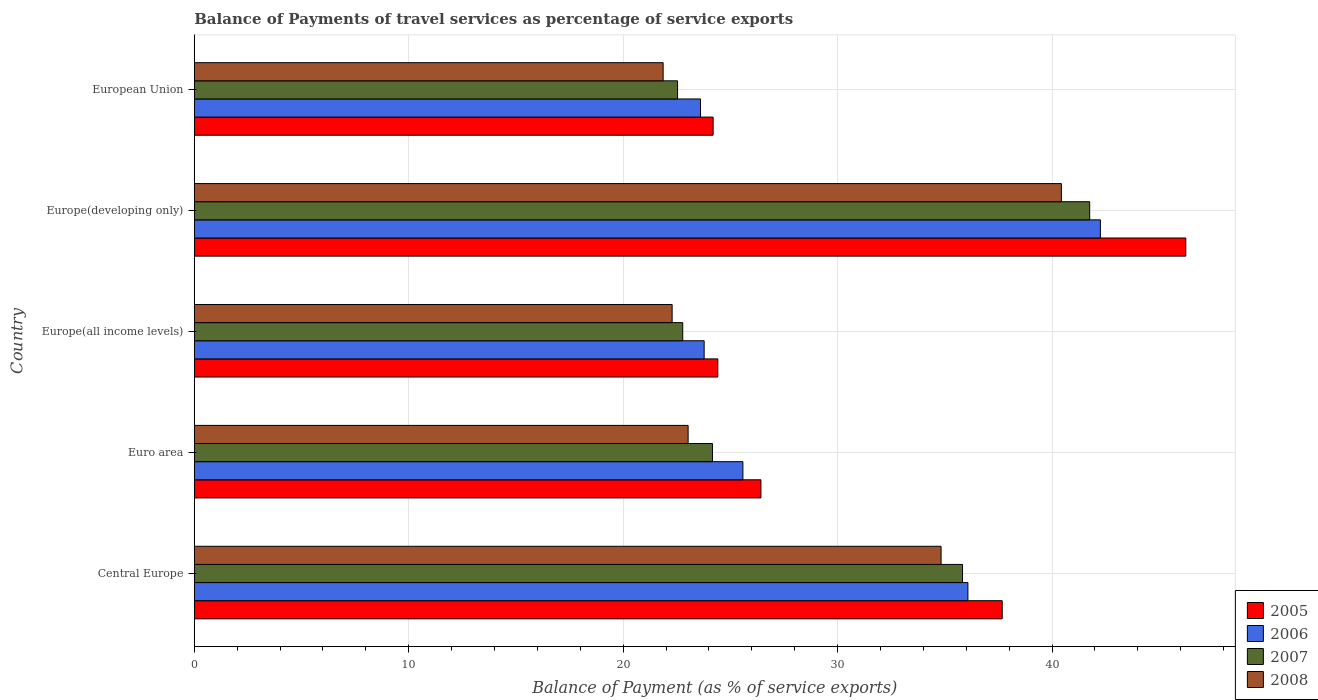How many different coloured bars are there?
Keep it short and to the point. 4. How many groups of bars are there?
Provide a succinct answer. 5. Are the number of bars per tick equal to the number of legend labels?
Provide a succinct answer. Yes. Are the number of bars on each tick of the Y-axis equal?
Ensure brevity in your answer.  Yes. How many bars are there on the 5th tick from the top?
Your response must be concise. 4. What is the balance of payments of travel services in 2005 in Europe(all income levels)?
Your answer should be very brief. 24.41. Across all countries, what is the maximum balance of payments of travel services in 2007?
Keep it short and to the point. 41.76. Across all countries, what is the minimum balance of payments of travel services in 2006?
Keep it short and to the point. 23.61. In which country was the balance of payments of travel services in 2005 maximum?
Give a very brief answer. Europe(developing only). What is the total balance of payments of travel services in 2005 in the graph?
Give a very brief answer. 158.95. What is the difference between the balance of payments of travel services in 2007 in Central Europe and that in Euro area?
Your answer should be very brief. 11.66. What is the difference between the balance of payments of travel services in 2005 in Europe(developing only) and the balance of payments of travel services in 2008 in European Union?
Your answer should be compact. 24.37. What is the average balance of payments of travel services in 2007 per country?
Provide a succinct answer. 29.41. What is the difference between the balance of payments of travel services in 2007 and balance of payments of travel services in 2005 in Euro area?
Offer a terse response. -2.26. What is the ratio of the balance of payments of travel services in 2006 in Europe(developing only) to that in European Union?
Ensure brevity in your answer.  1.79. Is the balance of payments of travel services in 2006 in Euro area less than that in Europe(developing only)?
Provide a short and direct response. Yes. What is the difference between the highest and the second highest balance of payments of travel services in 2005?
Provide a succinct answer. 8.56. What is the difference between the highest and the lowest balance of payments of travel services in 2005?
Offer a terse response. 22.04. Is the sum of the balance of payments of travel services in 2007 in Central Europe and Euro area greater than the maximum balance of payments of travel services in 2006 across all countries?
Your answer should be compact. Yes. What does the 1st bar from the top in European Union represents?
Your answer should be compact. 2008. What does the 4th bar from the bottom in European Union represents?
Your response must be concise. 2008. How many bars are there?
Make the answer very short. 20. Are all the bars in the graph horizontal?
Make the answer very short. Yes. How many countries are there in the graph?
Provide a succinct answer. 5. Does the graph contain grids?
Keep it short and to the point. Yes. How many legend labels are there?
Offer a terse response. 4. How are the legend labels stacked?
Your answer should be compact. Vertical. What is the title of the graph?
Keep it short and to the point. Balance of Payments of travel services as percentage of service exports. Does "1992" appear as one of the legend labels in the graph?
Your answer should be very brief. No. What is the label or title of the X-axis?
Provide a short and direct response. Balance of Payment (as % of service exports). What is the label or title of the Y-axis?
Make the answer very short. Country. What is the Balance of Payment (as % of service exports) in 2005 in Central Europe?
Provide a short and direct response. 37.68. What is the Balance of Payment (as % of service exports) of 2006 in Central Europe?
Keep it short and to the point. 36.08. What is the Balance of Payment (as % of service exports) in 2007 in Central Europe?
Ensure brevity in your answer.  35.83. What is the Balance of Payment (as % of service exports) of 2008 in Central Europe?
Keep it short and to the point. 34.83. What is the Balance of Payment (as % of service exports) of 2005 in Euro area?
Keep it short and to the point. 26.42. What is the Balance of Payment (as % of service exports) in 2006 in Euro area?
Offer a terse response. 25.58. What is the Balance of Payment (as % of service exports) in 2007 in Euro area?
Make the answer very short. 24.17. What is the Balance of Payment (as % of service exports) in 2008 in Euro area?
Provide a short and direct response. 23.03. What is the Balance of Payment (as % of service exports) in 2005 in Europe(all income levels)?
Offer a very short reply. 24.41. What is the Balance of Payment (as % of service exports) in 2006 in Europe(all income levels)?
Your answer should be compact. 23.78. What is the Balance of Payment (as % of service exports) in 2007 in Europe(all income levels)?
Your answer should be very brief. 22.78. What is the Balance of Payment (as % of service exports) in 2008 in Europe(all income levels)?
Your response must be concise. 22.28. What is the Balance of Payment (as % of service exports) of 2005 in Europe(developing only)?
Offer a terse response. 46.24. What is the Balance of Payment (as % of service exports) of 2006 in Europe(developing only)?
Offer a terse response. 42.25. What is the Balance of Payment (as % of service exports) of 2007 in Europe(developing only)?
Offer a terse response. 41.76. What is the Balance of Payment (as % of service exports) of 2008 in Europe(developing only)?
Offer a very short reply. 40.43. What is the Balance of Payment (as % of service exports) in 2005 in European Union?
Your response must be concise. 24.19. What is the Balance of Payment (as % of service exports) in 2006 in European Union?
Your response must be concise. 23.61. What is the Balance of Payment (as % of service exports) in 2007 in European Union?
Give a very brief answer. 22.54. What is the Balance of Payment (as % of service exports) of 2008 in European Union?
Provide a succinct answer. 21.86. Across all countries, what is the maximum Balance of Payment (as % of service exports) of 2005?
Keep it short and to the point. 46.24. Across all countries, what is the maximum Balance of Payment (as % of service exports) in 2006?
Ensure brevity in your answer.  42.25. Across all countries, what is the maximum Balance of Payment (as % of service exports) in 2007?
Make the answer very short. 41.76. Across all countries, what is the maximum Balance of Payment (as % of service exports) of 2008?
Your answer should be very brief. 40.43. Across all countries, what is the minimum Balance of Payment (as % of service exports) in 2005?
Offer a terse response. 24.19. Across all countries, what is the minimum Balance of Payment (as % of service exports) of 2006?
Offer a very short reply. 23.61. Across all countries, what is the minimum Balance of Payment (as % of service exports) of 2007?
Keep it short and to the point. 22.54. Across all countries, what is the minimum Balance of Payment (as % of service exports) in 2008?
Your answer should be very brief. 21.86. What is the total Balance of Payment (as % of service exports) in 2005 in the graph?
Provide a succinct answer. 158.95. What is the total Balance of Payment (as % of service exports) in 2006 in the graph?
Provide a short and direct response. 151.3. What is the total Balance of Payment (as % of service exports) of 2007 in the graph?
Keep it short and to the point. 147.06. What is the total Balance of Payment (as % of service exports) in 2008 in the graph?
Provide a succinct answer. 142.44. What is the difference between the Balance of Payment (as % of service exports) in 2005 in Central Europe and that in Euro area?
Provide a short and direct response. 11.25. What is the difference between the Balance of Payment (as % of service exports) of 2006 in Central Europe and that in Euro area?
Keep it short and to the point. 10.49. What is the difference between the Balance of Payment (as % of service exports) in 2007 in Central Europe and that in Euro area?
Your answer should be compact. 11.66. What is the difference between the Balance of Payment (as % of service exports) in 2008 in Central Europe and that in Euro area?
Your answer should be compact. 11.8. What is the difference between the Balance of Payment (as % of service exports) in 2005 in Central Europe and that in Europe(all income levels)?
Offer a very short reply. 13.26. What is the difference between the Balance of Payment (as % of service exports) in 2006 in Central Europe and that in Europe(all income levels)?
Make the answer very short. 12.3. What is the difference between the Balance of Payment (as % of service exports) of 2007 in Central Europe and that in Europe(all income levels)?
Offer a very short reply. 13.05. What is the difference between the Balance of Payment (as % of service exports) in 2008 in Central Europe and that in Europe(all income levels)?
Your response must be concise. 12.54. What is the difference between the Balance of Payment (as % of service exports) in 2005 in Central Europe and that in Europe(developing only)?
Your answer should be very brief. -8.56. What is the difference between the Balance of Payment (as % of service exports) in 2006 in Central Europe and that in Europe(developing only)?
Make the answer very short. -6.18. What is the difference between the Balance of Payment (as % of service exports) in 2007 in Central Europe and that in Europe(developing only)?
Make the answer very short. -5.93. What is the difference between the Balance of Payment (as % of service exports) of 2008 in Central Europe and that in Europe(developing only)?
Offer a very short reply. -5.61. What is the difference between the Balance of Payment (as % of service exports) of 2005 in Central Europe and that in European Union?
Provide a succinct answer. 13.48. What is the difference between the Balance of Payment (as % of service exports) of 2006 in Central Europe and that in European Union?
Make the answer very short. 12.47. What is the difference between the Balance of Payment (as % of service exports) of 2007 in Central Europe and that in European Union?
Make the answer very short. 13.29. What is the difference between the Balance of Payment (as % of service exports) in 2008 in Central Europe and that in European Union?
Your answer should be compact. 12.96. What is the difference between the Balance of Payment (as % of service exports) in 2005 in Euro area and that in Europe(all income levels)?
Ensure brevity in your answer.  2.01. What is the difference between the Balance of Payment (as % of service exports) in 2006 in Euro area and that in Europe(all income levels)?
Offer a very short reply. 1.81. What is the difference between the Balance of Payment (as % of service exports) of 2007 in Euro area and that in Europe(all income levels)?
Your answer should be very brief. 1.39. What is the difference between the Balance of Payment (as % of service exports) in 2008 in Euro area and that in Europe(all income levels)?
Offer a terse response. 0.75. What is the difference between the Balance of Payment (as % of service exports) in 2005 in Euro area and that in Europe(developing only)?
Ensure brevity in your answer.  -19.81. What is the difference between the Balance of Payment (as % of service exports) in 2006 in Euro area and that in Europe(developing only)?
Give a very brief answer. -16.67. What is the difference between the Balance of Payment (as % of service exports) of 2007 in Euro area and that in Europe(developing only)?
Keep it short and to the point. -17.59. What is the difference between the Balance of Payment (as % of service exports) in 2008 in Euro area and that in Europe(developing only)?
Ensure brevity in your answer.  -17.41. What is the difference between the Balance of Payment (as % of service exports) in 2005 in Euro area and that in European Union?
Give a very brief answer. 2.23. What is the difference between the Balance of Payment (as % of service exports) in 2006 in Euro area and that in European Union?
Keep it short and to the point. 1.98. What is the difference between the Balance of Payment (as % of service exports) in 2007 in Euro area and that in European Union?
Offer a terse response. 1.63. What is the difference between the Balance of Payment (as % of service exports) of 2008 in Euro area and that in European Union?
Provide a short and direct response. 1.17. What is the difference between the Balance of Payment (as % of service exports) of 2005 in Europe(all income levels) and that in Europe(developing only)?
Your answer should be compact. -21.82. What is the difference between the Balance of Payment (as % of service exports) in 2006 in Europe(all income levels) and that in Europe(developing only)?
Give a very brief answer. -18.48. What is the difference between the Balance of Payment (as % of service exports) in 2007 in Europe(all income levels) and that in Europe(developing only)?
Give a very brief answer. -18.98. What is the difference between the Balance of Payment (as % of service exports) in 2008 in Europe(all income levels) and that in Europe(developing only)?
Your response must be concise. -18.15. What is the difference between the Balance of Payment (as % of service exports) of 2005 in Europe(all income levels) and that in European Union?
Your answer should be compact. 0.22. What is the difference between the Balance of Payment (as % of service exports) of 2006 in Europe(all income levels) and that in European Union?
Offer a very short reply. 0.17. What is the difference between the Balance of Payment (as % of service exports) in 2007 in Europe(all income levels) and that in European Union?
Give a very brief answer. 0.24. What is the difference between the Balance of Payment (as % of service exports) of 2008 in Europe(all income levels) and that in European Union?
Your answer should be very brief. 0.42. What is the difference between the Balance of Payment (as % of service exports) in 2005 in Europe(developing only) and that in European Union?
Offer a terse response. 22.04. What is the difference between the Balance of Payment (as % of service exports) in 2006 in Europe(developing only) and that in European Union?
Ensure brevity in your answer.  18.65. What is the difference between the Balance of Payment (as % of service exports) in 2007 in Europe(developing only) and that in European Union?
Keep it short and to the point. 19.22. What is the difference between the Balance of Payment (as % of service exports) in 2008 in Europe(developing only) and that in European Union?
Your response must be concise. 18.57. What is the difference between the Balance of Payment (as % of service exports) of 2005 in Central Europe and the Balance of Payment (as % of service exports) of 2006 in Euro area?
Offer a very short reply. 12.09. What is the difference between the Balance of Payment (as % of service exports) of 2005 in Central Europe and the Balance of Payment (as % of service exports) of 2007 in Euro area?
Your answer should be compact. 13.51. What is the difference between the Balance of Payment (as % of service exports) of 2005 in Central Europe and the Balance of Payment (as % of service exports) of 2008 in Euro area?
Provide a succinct answer. 14.65. What is the difference between the Balance of Payment (as % of service exports) of 2006 in Central Europe and the Balance of Payment (as % of service exports) of 2007 in Euro area?
Provide a short and direct response. 11.91. What is the difference between the Balance of Payment (as % of service exports) in 2006 in Central Europe and the Balance of Payment (as % of service exports) in 2008 in Euro area?
Your answer should be compact. 13.05. What is the difference between the Balance of Payment (as % of service exports) of 2007 in Central Europe and the Balance of Payment (as % of service exports) of 2008 in Euro area?
Give a very brief answer. 12.8. What is the difference between the Balance of Payment (as % of service exports) in 2005 in Central Europe and the Balance of Payment (as % of service exports) in 2006 in Europe(all income levels)?
Provide a succinct answer. 13.9. What is the difference between the Balance of Payment (as % of service exports) of 2005 in Central Europe and the Balance of Payment (as % of service exports) of 2007 in Europe(all income levels)?
Provide a succinct answer. 14.9. What is the difference between the Balance of Payment (as % of service exports) of 2005 in Central Europe and the Balance of Payment (as % of service exports) of 2008 in Europe(all income levels)?
Provide a succinct answer. 15.39. What is the difference between the Balance of Payment (as % of service exports) of 2006 in Central Europe and the Balance of Payment (as % of service exports) of 2007 in Europe(all income levels)?
Keep it short and to the point. 13.3. What is the difference between the Balance of Payment (as % of service exports) of 2006 in Central Europe and the Balance of Payment (as % of service exports) of 2008 in Europe(all income levels)?
Provide a succinct answer. 13.79. What is the difference between the Balance of Payment (as % of service exports) in 2007 in Central Europe and the Balance of Payment (as % of service exports) in 2008 in Europe(all income levels)?
Offer a very short reply. 13.54. What is the difference between the Balance of Payment (as % of service exports) in 2005 in Central Europe and the Balance of Payment (as % of service exports) in 2006 in Europe(developing only)?
Offer a very short reply. -4.58. What is the difference between the Balance of Payment (as % of service exports) in 2005 in Central Europe and the Balance of Payment (as % of service exports) in 2007 in Europe(developing only)?
Make the answer very short. -4.08. What is the difference between the Balance of Payment (as % of service exports) of 2005 in Central Europe and the Balance of Payment (as % of service exports) of 2008 in Europe(developing only)?
Keep it short and to the point. -2.76. What is the difference between the Balance of Payment (as % of service exports) of 2006 in Central Europe and the Balance of Payment (as % of service exports) of 2007 in Europe(developing only)?
Ensure brevity in your answer.  -5.68. What is the difference between the Balance of Payment (as % of service exports) of 2006 in Central Europe and the Balance of Payment (as % of service exports) of 2008 in Europe(developing only)?
Provide a succinct answer. -4.36. What is the difference between the Balance of Payment (as % of service exports) of 2007 in Central Europe and the Balance of Payment (as % of service exports) of 2008 in Europe(developing only)?
Offer a very short reply. -4.61. What is the difference between the Balance of Payment (as % of service exports) of 2005 in Central Europe and the Balance of Payment (as % of service exports) of 2006 in European Union?
Keep it short and to the point. 14.07. What is the difference between the Balance of Payment (as % of service exports) of 2005 in Central Europe and the Balance of Payment (as % of service exports) of 2007 in European Union?
Offer a very short reply. 15.14. What is the difference between the Balance of Payment (as % of service exports) in 2005 in Central Europe and the Balance of Payment (as % of service exports) in 2008 in European Union?
Your response must be concise. 15.81. What is the difference between the Balance of Payment (as % of service exports) in 2006 in Central Europe and the Balance of Payment (as % of service exports) in 2007 in European Union?
Your answer should be very brief. 13.54. What is the difference between the Balance of Payment (as % of service exports) in 2006 in Central Europe and the Balance of Payment (as % of service exports) in 2008 in European Union?
Make the answer very short. 14.21. What is the difference between the Balance of Payment (as % of service exports) of 2007 in Central Europe and the Balance of Payment (as % of service exports) of 2008 in European Union?
Provide a succinct answer. 13.96. What is the difference between the Balance of Payment (as % of service exports) in 2005 in Euro area and the Balance of Payment (as % of service exports) in 2006 in Europe(all income levels)?
Offer a very short reply. 2.65. What is the difference between the Balance of Payment (as % of service exports) in 2005 in Euro area and the Balance of Payment (as % of service exports) in 2007 in Europe(all income levels)?
Give a very brief answer. 3.65. What is the difference between the Balance of Payment (as % of service exports) of 2005 in Euro area and the Balance of Payment (as % of service exports) of 2008 in Europe(all income levels)?
Offer a very short reply. 4.14. What is the difference between the Balance of Payment (as % of service exports) in 2006 in Euro area and the Balance of Payment (as % of service exports) in 2007 in Europe(all income levels)?
Offer a terse response. 2.81. What is the difference between the Balance of Payment (as % of service exports) of 2006 in Euro area and the Balance of Payment (as % of service exports) of 2008 in Europe(all income levels)?
Provide a short and direct response. 3.3. What is the difference between the Balance of Payment (as % of service exports) of 2007 in Euro area and the Balance of Payment (as % of service exports) of 2008 in Europe(all income levels)?
Provide a short and direct response. 1.88. What is the difference between the Balance of Payment (as % of service exports) in 2005 in Euro area and the Balance of Payment (as % of service exports) in 2006 in Europe(developing only)?
Your response must be concise. -15.83. What is the difference between the Balance of Payment (as % of service exports) of 2005 in Euro area and the Balance of Payment (as % of service exports) of 2007 in Europe(developing only)?
Keep it short and to the point. -15.33. What is the difference between the Balance of Payment (as % of service exports) in 2005 in Euro area and the Balance of Payment (as % of service exports) in 2008 in Europe(developing only)?
Ensure brevity in your answer.  -14.01. What is the difference between the Balance of Payment (as % of service exports) in 2006 in Euro area and the Balance of Payment (as % of service exports) in 2007 in Europe(developing only)?
Offer a terse response. -16.17. What is the difference between the Balance of Payment (as % of service exports) in 2006 in Euro area and the Balance of Payment (as % of service exports) in 2008 in Europe(developing only)?
Your answer should be very brief. -14.85. What is the difference between the Balance of Payment (as % of service exports) in 2007 in Euro area and the Balance of Payment (as % of service exports) in 2008 in Europe(developing only)?
Make the answer very short. -16.27. What is the difference between the Balance of Payment (as % of service exports) in 2005 in Euro area and the Balance of Payment (as % of service exports) in 2006 in European Union?
Give a very brief answer. 2.82. What is the difference between the Balance of Payment (as % of service exports) in 2005 in Euro area and the Balance of Payment (as % of service exports) in 2007 in European Union?
Your response must be concise. 3.89. What is the difference between the Balance of Payment (as % of service exports) in 2005 in Euro area and the Balance of Payment (as % of service exports) in 2008 in European Union?
Provide a short and direct response. 4.56. What is the difference between the Balance of Payment (as % of service exports) of 2006 in Euro area and the Balance of Payment (as % of service exports) of 2007 in European Union?
Your response must be concise. 3.05. What is the difference between the Balance of Payment (as % of service exports) in 2006 in Euro area and the Balance of Payment (as % of service exports) in 2008 in European Union?
Offer a very short reply. 3.72. What is the difference between the Balance of Payment (as % of service exports) in 2007 in Euro area and the Balance of Payment (as % of service exports) in 2008 in European Union?
Provide a succinct answer. 2.3. What is the difference between the Balance of Payment (as % of service exports) of 2005 in Europe(all income levels) and the Balance of Payment (as % of service exports) of 2006 in Europe(developing only)?
Provide a succinct answer. -17.84. What is the difference between the Balance of Payment (as % of service exports) in 2005 in Europe(all income levels) and the Balance of Payment (as % of service exports) in 2007 in Europe(developing only)?
Provide a succinct answer. -17.34. What is the difference between the Balance of Payment (as % of service exports) in 2005 in Europe(all income levels) and the Balance of Payment (as % of service exports) in 2008 in Europe(developing only)?
Give a very brief answer. -16.02. What is the difference between the Balance of Payment (as % of service exports) of 2006 in Europe(all income levels) and the Balance of Payment (as % of service exports) of 2007 in Europe(developing only)?
Provide a succinct answer. -17.98. What is the difference between the Balance of Payment (as % of service exports) of 2006 in Europe(all income levels) and the Balance of Payment (as % of service exports) of 2008 in Europe(developing only)?
Your answer should be compact. -16.66. What is the difference between the Balance of Payment (as % of service exports) of 2007 in Europe(all income levels) and the Balance of Payment (as % of service exports) of 2008 in Europe(developing only)?
Offer a very short reply. -17.66. What is the difference between the Balance of Payment (as % of service exports) in 2005 in Europe(all income levels) and the Balance of Payment (as % of service exports) in 2006 in European Union?
Make the answer very short. 0.81. What is the difference between the Balance of Payment (as % of service exports) in 2005 in Europe(all income levels) and the Balance of Payment (as % of service exports) in 2007 in European Union?
Offer a terse response. 1.88. What is the difference between the Balance of Payment (as % of service exports) of 2005 in Europe(all income levels) and the Balance of Payment (as % of service exports) of 2008 in European Union?
Your answer should be compact. 2.55. What is the difference between the Balance of Payment (as % of service exports) of 2006 in Europe(all income levels) and the Balance of Payment (as % of service exports) of 2007 in European Union?
Keep it short and to the point. 1.24. What is the difference between the Balance of Payment (as % of service exports) of 2006 in Europe(all income levels) and the Balance of Payment (as % of service exports) of 2008 in European Union?
Offer a terse response. 1.91. What is the difference between the Balance of Payment (as % of service exports) of 2007 in Europe(all income levels) and the Balance of Payment (as % of service exports) of 2008 in European Union?
Your response must be concise. 0.91. What is the difference between the Balance of Payment (as % of service exports) in 2005 in Europe(developing only) and the Balance of Payment (as % of service exports) in 2006 in European Union?
Your response must be concise. 22.63. What is the difference between the Balance of Payment (as % of service exports) of 2005 in Europe(developing only) and the Balance of Payment (as % of service exports) of 2007 in European Union?
Give a very brief answer. 23.7. What is the difference between the Balance of Payment (as % of service exports) of 2005 in Europe(developing only) and the Balance of Payment (as % of service exports) of 2008 in European Union?
Provide a succinct answer. 24.37. What is the difference between the Balance of Payment (as % of service exports) in 2006 in Europe(developing only) and the Balance of Payment (as % of service exports) in 2007 in European Union?
Offer a terse response. 19.72. What is the difference between the Balance of Payment (as % of service exports) in 2006 in Europe(developing only) and the Balance of Payment (as % of service exports) in 2008 in European Union?
Your answer should be very brief. 20.39. What is the difference between the Balance of Payment (as % of service exports) in 2007 in Europe(developing only) and the Balance of Payment (as % of service exports) in 2008 in European Union?
Your response must be concise. 19.89. What is the average Balance of Payment (as % of service exports) in 2005 per country?
Your answer should be compact. 31.79. What is the average Balance of Payment (as % of service exports) in 2006 per country?
Your answer should be compact. 30.26. What is the average Balance of Payment (as % of service exports) of 2007 per country?
Give a very brief answer. 29.41. What is the average Balance of Payment (as % of service exports) of 2008 per country?
Ensure brevity in your answer.  28.49. What is the difference between the Balance of Payment (as % of service exports) of 2005 and Balance of Payment (as % of service exports) of 2006 in Central Europe?
Your answer should be compact. 1.6. What is the difference between the Balance of Payment (as % of service exports) of 2005 and Balance of Payment (as % of service exports) of 2007 in Central Europe?
Offer a very short reply. 1.85. What is the difference between the Balance of Payment (as % of service exports) in 2005 and Balance of Payment (as % of service exports) in 2008 in Central Europe?
Ensure brevity in your answer.  2.85. What is the difference between the Balance of Payment (as % of service exports) of 2006 and Balance of Payment (as % of service exports) of 2007 in Central Europe?
Keep it short and to the point. 0.25. What is the difference between the Balance of Payment (as % of service exports) of 2006 and Balance of Payment (as % of service exports) of 2008 in Central Europe?
Make the answer very short. 1.25. What is the difference between the Balance of Payment (as % of service exports) in 2007 and Balance of Payment (as % of service exports) in 2008 in Central Europe?
Make the answer very short. 1. What is the difference between the Balance of Payment (as % of service exports) of 2005 and Balance of Payment (as % of service exports) of 2006 in Euro area?
Provide a succinct answer. 0.84. What is the difference between the Balance of Payment (as % of service exports) in 2005 and Balance of Payment (as % of service exports) in 2007 in Euro area?
Provide a succinct answer. 2.26. What is the difference between the Balance of Payment (as % of service exports) of 2005 and Balance of Payment (as % of service exports) of 2008 in Euro area?
Offer a terse response. 3.4. What is the difference between the Balance of Payment (as % of service exports) of 2006 and Balance of Payment (as % of service exports) of 2007 in Euro area?
Ensure brevity in your answer.  1.42. What is the difference between the Balance of Payment (as % of service exports) in 2006 and Balance of Payment (as % of service exports) in 2008 in Euro area?
Make the answer very short. 2.55. What is the difference between the Balance of Payment (as % of service exports) of 2007 and Balance of Payment (as % of service exports) of 2008 in Euro area?
Offer a terse response. 1.14. What is the difference between the Balance of Payment (as % of service exports) of 2005 and Balance of Payment (as % of service exports) of 2006 in Europe(all income levels)?
Offer a very short reply. 0.64. What is the difference between the Balance of Payment (as % of service exports) of 2005 and Balance of Payment (as % of service exports) of 2007 in Europe(all income levels)?
Your response must be concise. 1.64. What is the difference between the Balance of Payment (as % of service exports) in 2005 and Balance of Payment (as % of service exports) in 2008 in Europe(all income levels)?
Keep it short and to the point. 2.13. What is the difference between the Balance of Payment (as % of service exports) in 2006 and Balance of Payment (as % of service exports) in 2007 in Europe(all income levels)?
Make the answer very short. 1. What is the difference between the Balance of Payment (as % of service exports) of 2006 and Balance of Payment (as % of service exports) of 2008 in Europe(all income levels)?
Your response must be concise. 1.49. What is the difference between the Balance of Payment (as % of service exports) of 2007 and Balance of Payment (as % of service exports) of 2008 in Europe(all income levels)?
Provide a succinct answer. 0.49. What is the difference between the Balance of Payment (as % of service exports) of 2005 and Balance of Payment (as % of service exports) of 2006 in Europe(developing only)?
Give a very brief answer. 3.98. What is the difference between the Balance of Payment (as % of service exports) in 2005 and Balance of Payment (as % of service exports) in 2007 in Europe(developing only)?
Provide a succinct answer. 4.48. What is the difference between the Balance of Payment (as % of service exports) in 2005 and Balance of Payment (as % of service exports) in 2008 in Europe(developing only)?
Your answer should be very brief. 5.8. What is the difference between the Balance of Payment (as % of service exports) of 2006 and Balance of Payment (as % of service exports) of 2007 in Europe(developing only)?
Provide a short and direct response. 0.5. What is the difference between the Balance of Payment (as % of service exports) of 2006 and Balance of Payment (as % of service exports) of 2008 in Europe(developing only)?
Provide a short and direct response. 1.82. What is the difference between the Balance of Payment (as % of service exports) in 2007 and Balance of Payment (as % of service exports) in 2008 in Europe(developing only)?
Provide a short and direct response. 1.32. What is the difference between the Balance of Payment (as % of service exports) in 2005 and Balance of Payment (as % of service exports) in 2006 in European Union?
Your answer should be compact. 0.59. What is the difference between the Balance of Payment (as % of service exports) of 2005 and Balance of Payment (as % of service exports) of 2007 in European Union?
Ensure brevity in your answer.  1.66. What is the difference between the Balance of Payment (as % of service exports) of 2005 and Balance of Payment (as % of service exports) of 2008 in European Union?
Offer a very short reply. 2.33. What is the difference between the Balance of Payment (as % of service exports) in 2006 and Balance of Payment (as % of service exports) in 2007 in European Union?
Provide a short and direct response. 1.07. What is the difference between the Balance of Payment (as % of service exports) in 2006 and Balance of Payment (as % of service exports) in 2008 in European Union?
Make the answer very short. 1.74. What is the difference between the Balance of Payment (as % of service exports) in 2007 and Balance of Payment (as % of service exports) in 2008 in European Union?
Keep it short and to the point. 0.67. What is the ratio of the Balance of Payment (as % of service exports) of 2005 in Central Europe to that in Euro area?
Give a very brief answer. 1.43. What is the ratio of the Balance of Payment (as % of service exports) of 2006 in Central Europe to that in Euro area?
Offer a very short reply. 1.41. What is the ratio of the Balance of Payment (as % of service exports) of 2007 in Central Europe to that in Euro area?
Give a very brief answer. 1.48. What is the ratio of the Balance of Payment (as % of service exports) in 2008 in Central Europe to that in Euro area?
Give a very brief answer. 1.51. What is the ratio of the Balance of Payment (as % of service exports) of 2005 in Central Europe to that in Europe(all income levels)?
Offer a very short reply. 1.54. What is the ratio of the Balance of Payment (as % of service exports) of 2006 in Central Europe to that in Europe(all income levels)?
Offer a terse response. 1.52. What is the ratio of the Balance of Payment (as % of service exports) in 2007 in Central Europe to that in Europe(all income levels)?
Give a very brief answer. 1.57. What is the ratio of the Balance of Payment (as % of service exports) of 2008 in Central Europe to that in Europe(all income levels)?
Provide a succinct answer. 1.56. What is the ratio of the Balance of Payment (as % of service exports) of 2005 in Central Europe to that in Europe(developing only)?
Ensure brevity in your answer.  0.81. What is the ratio of the Balance of Payment (as % of service exports) in 2006 in Central Europe to that in Europe(developing only)?
Give a very brief answer. 0.85. What is the ratio of the Balance of Payment (as % of service exports) of 2007 in Central Europe to that in Europe(developing only)?
Keep it short and to the point. 0.86. What is the ratio of the Balance of Payment (as % of service exports) in 2008 in Central Europe to that in Europe(developing only)?
Offer a terse response. 0.86. What is the ratio of the Balance of Payment (as % of service exports) in 2005 in Central Europe to that in European Union?
Your answer should be compact. 1.56. What is the ratio of the Balance of Payment (as % of service exports) in 2006 in Central Europe to that in European Union?
Keep it short and to the point. 1.53. What is the ratio of the Balance of Payment (as % of service exports) of 2007 in Central Europe to that in European Union?
Your answer should be compact. 1.59. What is the ratio of the Balance of Payment (as % of service exports) of 2008 in Central Europe to that in European Union?
Ensure brevity in your answer.  1.59. What is the ratio of the Balance of Payment (as % of service exports) in 2005 in Euro area to that in Europe(all income levels)?
Provide a succinct answer. 1.08. What is the ratio of the Balance of Payment (as % of service exports) of 2006 in Euro area to that in Europe(all income levels)?
Keep it short and to the point. 1.08. What is the ratio of the Balance of Payment (as % of service exports) of 2007 in Euro area to that in Europe(all income levels)?
Provide a succinct answer. 1.06. What is the ratio of the Balance of Payment (as % of service exports) in 2008 in Euro area to that in Europe(all income levels)?
Offer a terse response. 1.03. What is the ratio of the Balance of Payment (as % of service exports) of 2005 in Euro area to that in Europe(developing only)?
Your response must be concise. 0.57. What is the ratio of the Balance of Payment (as % of service exports) in 2006 in Euro area to that in Europe(developing only)?
Your answer should be very brief. 0.61. What is the ratio of the Balance of Payment (as % of service exports) of 2007 in Euro area to that in Europe(developing only)?
Ensure brevity in your answer.  0.58. What is the ratio of the Balance of Payment (as % of service exports) in 2008 in Euro area to that in Europe(developing only)?
Offer a terse response. 0.57. What is the ratio of the Balance of Payment (as % of service exports) in 2005 in Euro area to that in European Union?
Keep it short and to the point. 1.09. What is the ratio of the Balance of Payment (as % of service exports) of 2006 in Euro area to that in European Union?
Your answer should be compact. 1.08. What is the ratio of the Balance of Payment (as % of service exports) of 2007 in Euro area to that in European Union?
Provide a succinct answer. 1.07. What is the ratio of the Balance of Payment (as % of service exports) in 2008 in Euro area to that in European Union?
Keep it short and to the point. 1.05. What is the ratio of the Balance of Payment (as % of service exports) of 2005 in Europe(all income levels) to that in Europe(developing only)?
Offer a very short reply. 0.53. What is the ratio of the Balance of Payment (as % of service exports) of 2006 in Europe(all income levels) to that in Europe(developing only)?
Offer a very short reply. 0.56. What is the ratio of the Balance of Payment (as % of service exports) in 2007 in Europe(all income levels) to that in Europe(developing only)?
Offer a terse response. 0.55. What is the ratio of the Balance of Payment (as % of service exports) in 2008 in Europe(all income levels) to that in Europe(developing only)?
Make the answer very short. 0.55. What is the ratio of the Balance of Payment (as % of service exports) in 2005 in Europe(all income levels) to that in European Union?
Ensure brevity in your answer.  1.01. What is the ratio of the Balance of Payment (as % of service exports) of 2006 in Europe(all income levels) to that in European Union?
Provide a succinct answer. 1.01. What is the ratio of the Balance of Payment (as % of service exports) of 2007 in Europe(all income levels) to that in European Union?
Provide a short and direct response. 1.01. What is the ratio of the Balance of Payment (as % of service exports) in 2008 in Europe(all income levels) to that in European Union?
Your response must be concise. 1.02. What is the ratio of the Balance of Payment (as % of service exports) of 2005 in Europe(developing only) to that in European Union?
Keep it short and to the point. 1.91. What is the ratio of the Balance of Payment (as % of service exports) of 2006 in Europe(developing only) to that in European Union?
Offer a terse response. 1.79. What is the ratio of the Balance of Payment (as % of service exports) of 2007 in Europe(developing only) to that in European Union?
Your answer should be compact. 1.85. What is the ratio of the Balance of Payment (as % of service exports) of 2008 in Europe(developing only) to that in European Union?
Offer a very short reply. 1.85. What is the difference between the highest and the second highest Balance of Payment (as % of service exports) in 2005?
Ensure brevity in your answer.  8.56. What is the difference between the highest and the second highest Balance of Payment (as % of service exports) in 2006?
Offer a very short reply. 6.18. What is the difference between the highest and the second highest Balance of Payment (as % of service exports) of 2007?
Provide a short and direct response. 5.93. What is the difference between the highest and the second highest Balance of Payment (as % of service exports) of 2008?
Provide a short and direct response. 5.61. What is the difference between the highest and the lowest Balance of Payment (as % of service exports) in 2005?
Your answer should be compact. 22.04. What is the difference between the highest and the lowest Balance of Payment (as % of service exports) of 2006?
Your answer should be compact. 18.65. What is the difference between the highest and the lowest Balance of Payment (as % of service exports) in 2007?
Offer a very short reply. 19.22. What is the difference between the highest and the lowest Balance of Payment (as % of service exports) in 2008?
Offer a terse response. 18.57. 